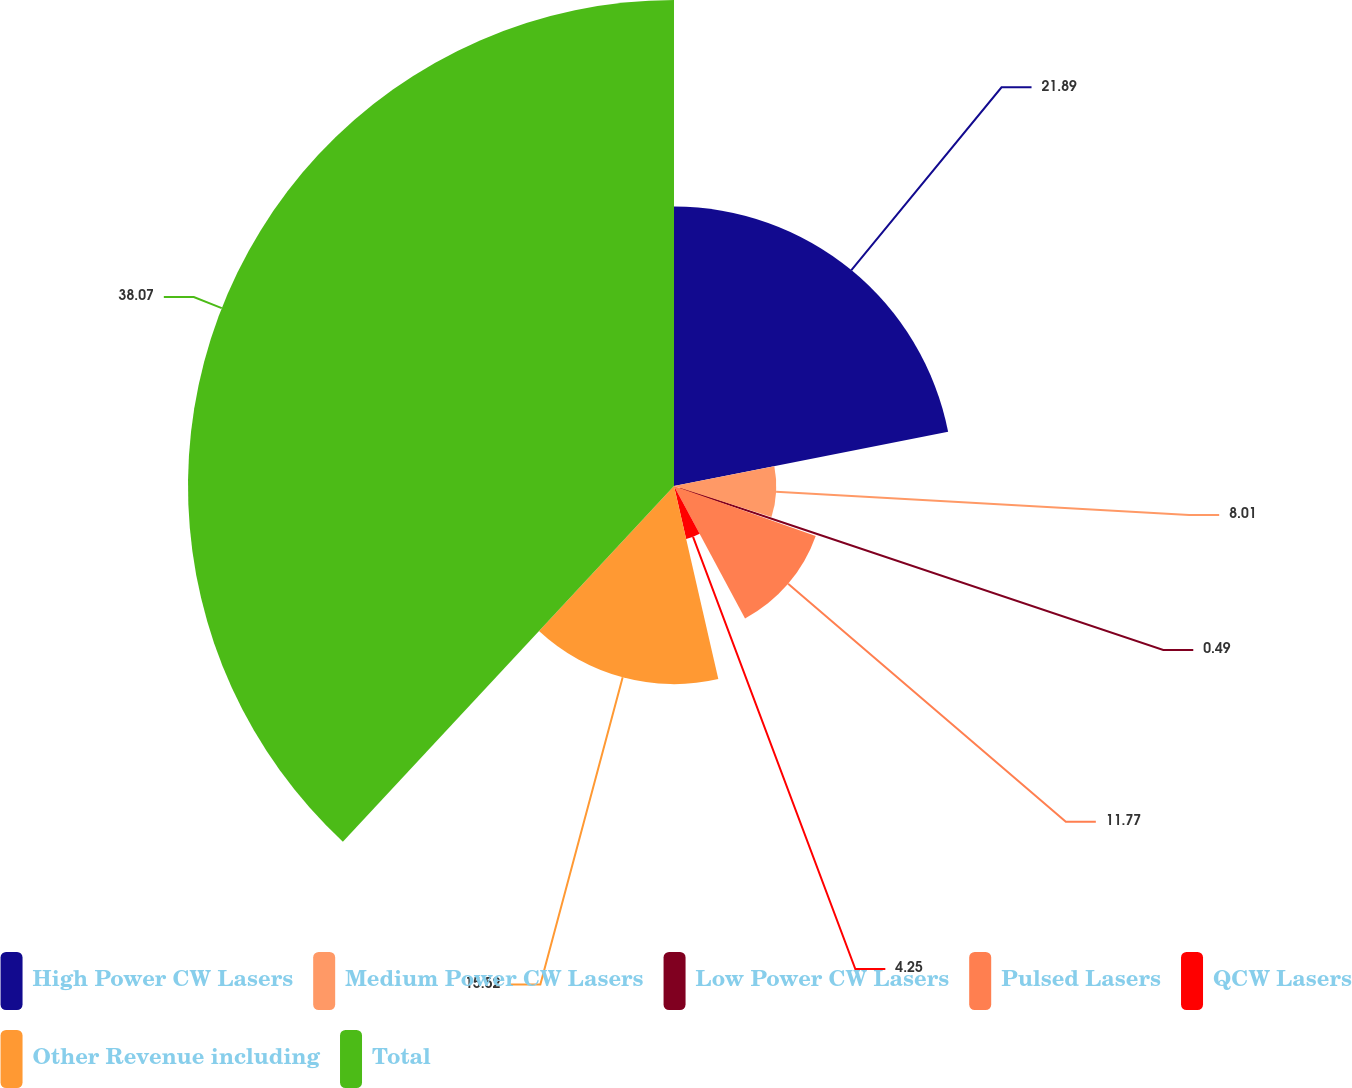Convert chart to OTSL. <chart><loc_0><loc_0><loc_500><loc_500><pie_chart><fcel>High Power CW Lasers<fcel>Medium Power CW Lasers<fcel>Low Power CW Lasers<fcel>Pulsed Lasers<fcel>QCW Lasers<fcel>Other Revenue including<fcel>Total<nl><fcel>21.89%<fcel>8.01%<fcel>0.49%<fcel>11.77%<fcel>4.25%<fcel>15.52%<fcel>38.07%<nl></chart> 